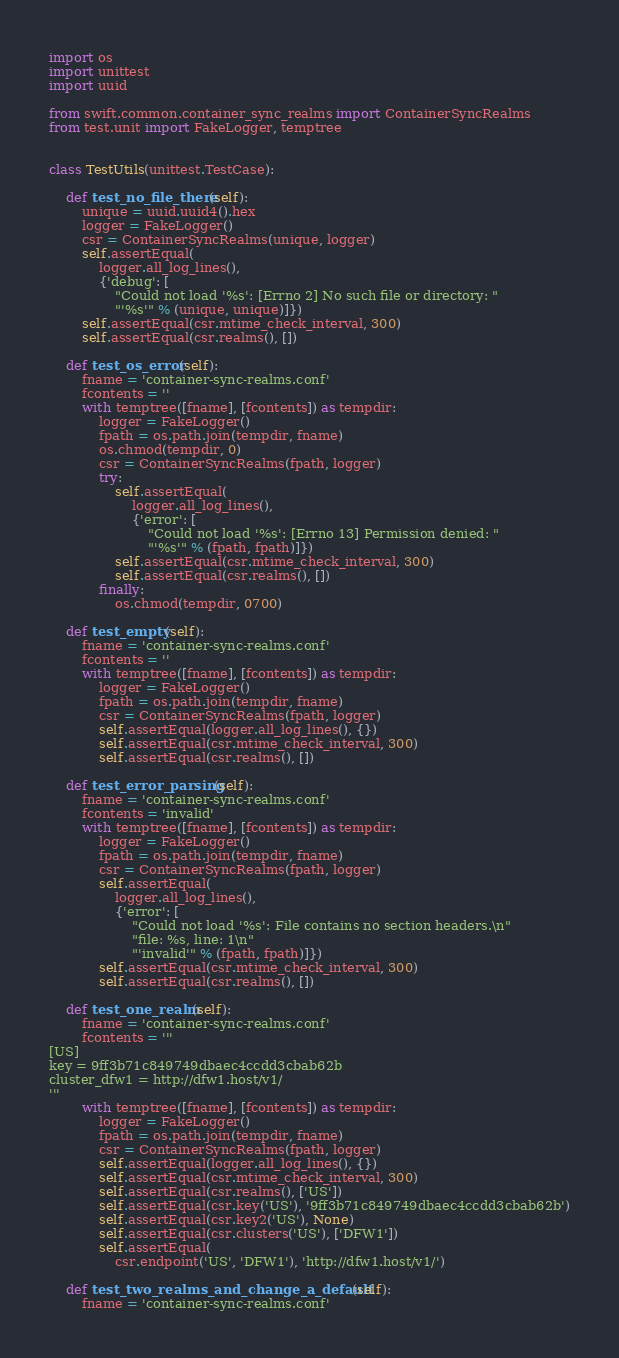Convert code to text. <code><loc_0><loc_0><loc_500><loc_500><_Python_>
import os
import unittest
import uuid

from swift.common.container_sync_realms import ContainerSyncRealms
from test.unit import FakeLogger, temptree


class TestUtils(unittest.TestCase):

    def test_no_file_there(self):
        unique = uuid.uuid4().hex
        logger = FakeLogger()
        csr = ContainerSyncRealms(unique, logger)
        self.assertEqual(
            logger.all_log_lines(),
            {'debug': [
                "Could not load '%s': [Errno 2] No such file or directory: "
                "'%s'" % (unique, unique)]})
        self.assertEqual(csr.mtime_check_interval, 300)
        self.assertEqual(csr.realms(), [])

    def test_os_error(self):
        fname = 'container-sync-realms.conf'
        fcontents = ''
        with temptree([fname], [fcontents]) as tempdir:
            logger = FakeLogger()
            fpath = os.path.join(tempdir, fname)
            os.chmod(tempdir, 0)
            csr = ContainerSyncRealms(fpath, logger)
            try:
                self.assertEqual(
                    logger.all_log_lines(),
                    {'error': [
                        "Could not load '%s': [Errno 13] Permission denied: "
                        "'%s'" % (fpath, fpath)]})
                self.assertEqual(csr.mtime_check_interval, 300)
                self.assertEqual(csr.realms(), [])
            finally:
                os.chmod(tempdir, 0700)

    def test_empty(self):
        fname = 'container-sync-realms.conf'
        fcontents = ''
        with temptree([fname], [fcontents]) as tempdir:
            logger = FakeLogger()
            fpath = os.path.join(tempdir, fname)
            csr = ContainerSyncRealms(fpath, logger)
            self.assertEqual(logger.all_log_lines(), {})
            self.assertEqual(csr.mtime_check_interval, 300)
            self.assertEqual(csr.realms(), [])

    def test_error_parsing(self):
        fname = 'container-sync-realms.conf'
        fcontents = 'invalid'
        with temptree([fname], [fcontents]) as tempdir:
            logger = FakeLogger()
            fpath = os.path.join(tempdir, fname)
            csr = ContainerSyncRealms(fpath, logger)
            self.assertEqual(
                logger.all_log_lines(),
                {'error': [
                    "Could not load '%s': File contains no section headers.\n"
                    "file: %s, line: 1\n"
                    "'invalid'" % (fpath, fpath)]})
            self.assertEqual(csr.mtime_check_interval, 300)
            self.assertEqual(csr.realms(), [])

    def test_one_realm(self):
        fname = 'container-sync-realms.conf'
        fcontents = '''
[US]
key = 9ff3b71c849749dbaec4ccdd3cbab62b
cluster_dfw1 = http://dfw1.host/v1/
'''
        with temptree([fname], [fcontents]) as tempdir:
            logger = FakeLogger()
            fpath = os.path.join(tempdir, fname)
            csr = ContainerSyncRealms(fpath, logger)
            self.assertEqual(logger.all_log_lines(), {})
            self.assertEqual(csr.mtime_check_interval, 300)
            self.assertEqual(csr.realms(), ['US'])
            self.assertEqual(csr.key('US'), '9ff3b71c849749dbaec4ccdd3cbab62b')
            self.assertEqual(csr.key2('US'), None)
            self.assertEqual(csr.clusters('US'), ['DFW1'])
            self.assertEqual(
                csr.endpoint('US', 'DFW1'), 'http://dfw1.host/v1/')

    def test_two_realms_and_change_a_default(self):
        fname = 'container-sync-realms.conf'</code> 